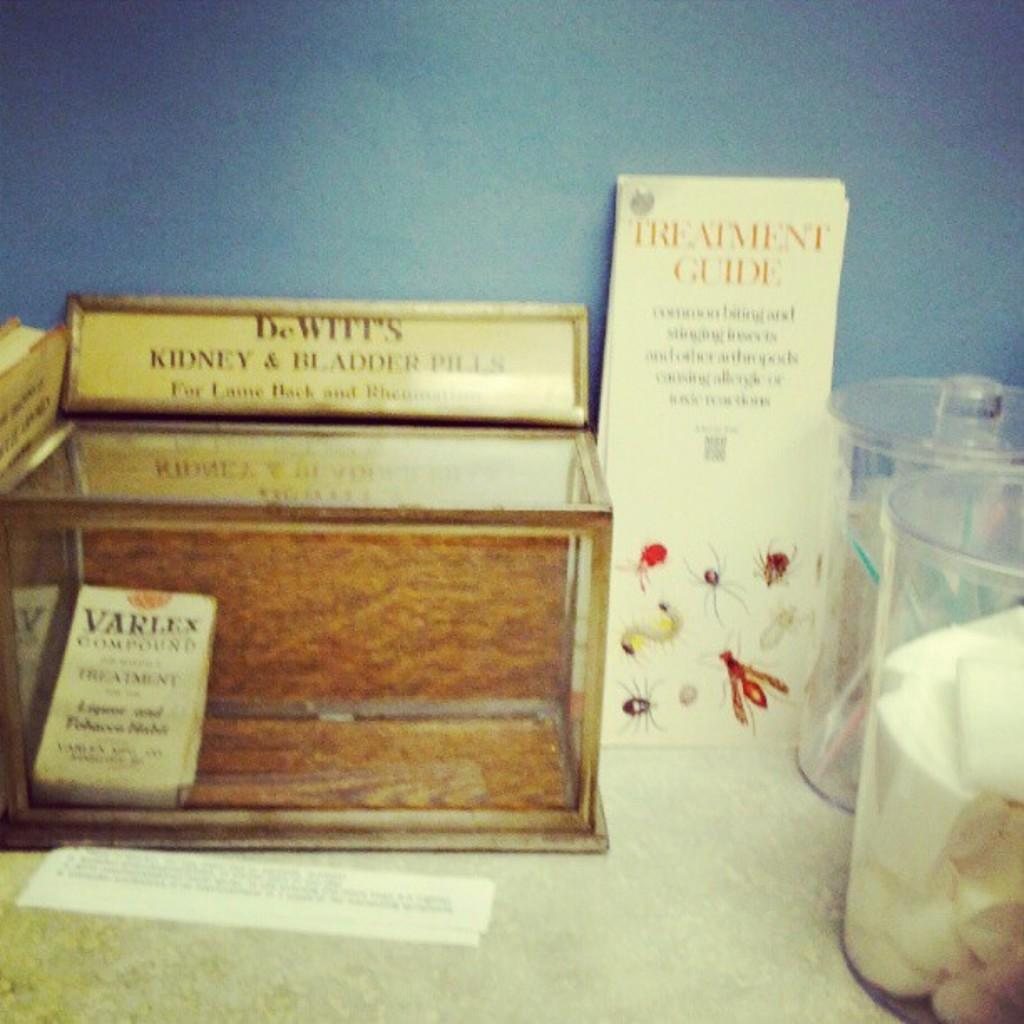<image>
Render a clear and concise summary of the photo. wooden box with Dewitts kidney and bladder pills and a brochure with bugs 